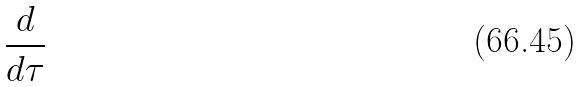<formula> <loc_0><loc_0><loc_500><loc_500>\frac { d } { d \tau }</formula> 